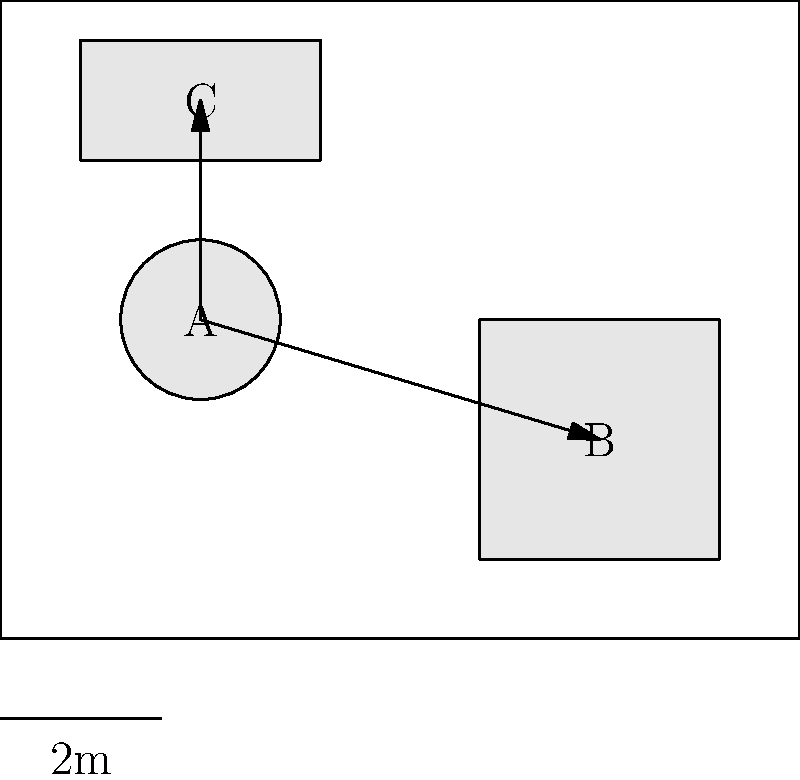In the diagram above, three pieces of furniture (A, B, and C) are arranged in a room. Which principle of furniture arrangement for maximizing space utilization is best illustrated by the placement of these items? To answer this question, let's analyze the furniture arrangement principles illustrated in the diagram:

1. Circular item A (likely a round table or ottoman) is placed centrally in the room.
2. Rectangular item B (possibly a sofa or cabinet) is positioned along the right wall.
3. Smaller rectangular item C (perhaps a chair or side table) is placed in the upper left corner.
4. There are clear pathways between the furniture pieces, as indicated by the arrows.

The arrangement demonstrates several key principles:

a) Traffic Flow: The arrows show clear paths between furniture pieces, allowing for easy movement throughout the room.

b) Zoning: The furniture is grouped to create distinct areas within the room, likely for different functions.

c) Wall Alignment: Item B is placed against the wall, maximizing open floor space.

d) Corner Utilization: Item C makes use of a corner, often an underutilized space.

e) Focal Point: Item A, being central, could serve as a focal point for the room.

However, the most prominent principle illustrated here is the concept of traffic flow. The arrows clearly indicate pathways between furniture pieces, ensuring easy movement and accessibility. This arrangement maximizes usable space by creating clear circulation routes, which is crucial for efficient space utilization in interior design.
Answer: Traffic flow 